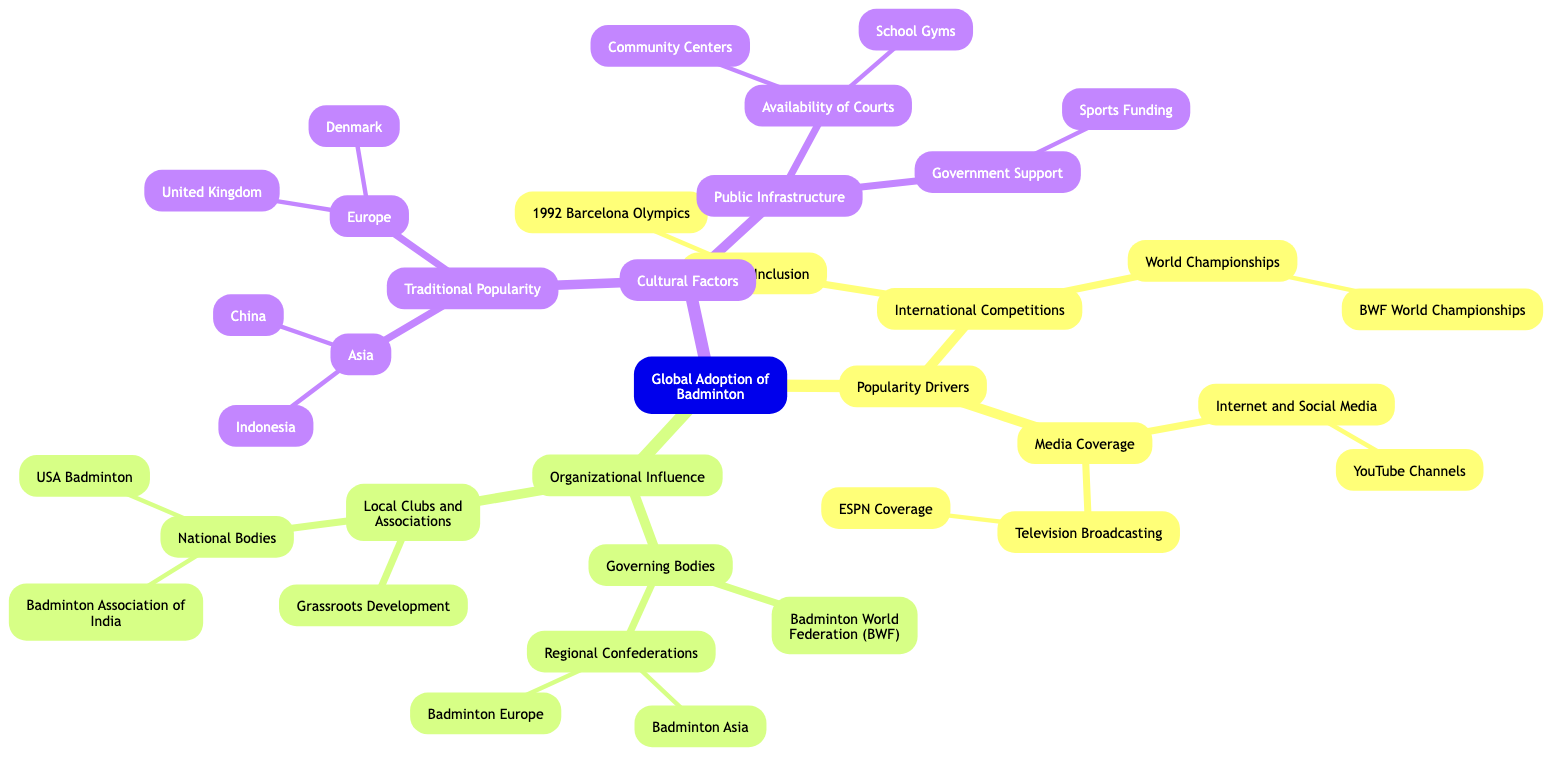What are the primary categories influencing the global adoption of badminton? The diagram shows three primary categories: Popularity Drivers, Organizational Influence, and Cultural Factors, which are the main branches off the root node "Global Adoption of Badminton."
Answer: Popularity Drivers, Organizational Influence, Cultural Factors How many children nodes does the "Popularity Drivers" category have? By examining the diagram, "Popularity Drivers" has two children nodes: "International Competitions" and "Media Coverage." Therefore, the count is two.
Answer: 2 What event is listed under "Olympic Inclusion"? The diagram specifies "1992 Barcelona Olympics" as the event listed under the sub-category "Olympic Inclusion." Thus, the answer is directly derived from that node.
Answer: 1992 Barcelona Olympics Which organization is at the top of the "Organizational Influence" structure? The diagram indicates that "Governing Bodies" is the primary child node under "Organizational Influence," making it the top organization in this context.
Answer: Governing Bodies Name two countries mentioned under "Traditional Popularity" in Asia. In examining the "Traditional Popularity" sub-category, it is clear that both "China" and "Indonesia" are listed as examples of countries with notable popularity. Thus, these are the answers sought from the diagram.
Answer: China, Indonesia What is one factor contributing to "Public Infrastructure"? The diagram outlines "Availability of Courts" and "Government Support" as child nodes under "Public Infrastructure." Therefore, either of these can be a valid answer, but using one for clarity, "Availability of Courts" is a straightforward example.
Answer: Availability of Courts Which governing body is responsible for international governance of badminton? The diagram identifies "Badminton World Federation (BWF)" as a governing body, indicating its direct connection to international governance in the sport of badminton.
Answer: Badminton World Federation How many regional confederations are listed under "Governing Bodies"? The diagram depicts two specific regional confederations: "Badminton Asia" and "Badminton Europe," found under the "Governing Bodies" category. Therefore, the answer is based on counting these two distinct nodes.
Answer: 2 What type of media coverage is specifically mentioned under "Media Coverage"? The "Media Coverage" category includes various forms of coverage, specifically highlighting "Television Broadcasting" and "Internet and Social Media." Hence, "Television Broadcasting" is a specific type mentioned in the diagram.
Answer: Television Broadcasting 